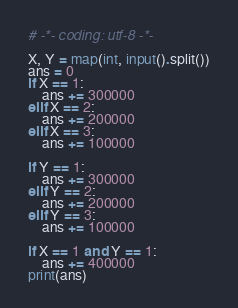Convert code to text. <code><loc_0><loc_0><loc_500><loc_500><_Python_># -*- coding: utf-8 -*-

X, Y = map(int, input().split())
ans = 0
if X == 1:
    ans += 300000
elif X == 2:
    ans += 200000
elif X == 3:
    ans += 100000
    
if Y == 1:
    ans += 300000
elif Y == 2:
    ans += 200000
elif Y == 3:
    ans += 100000

if X == 1 and Y == 1:
    ans += 400000
print(ans)</code> 